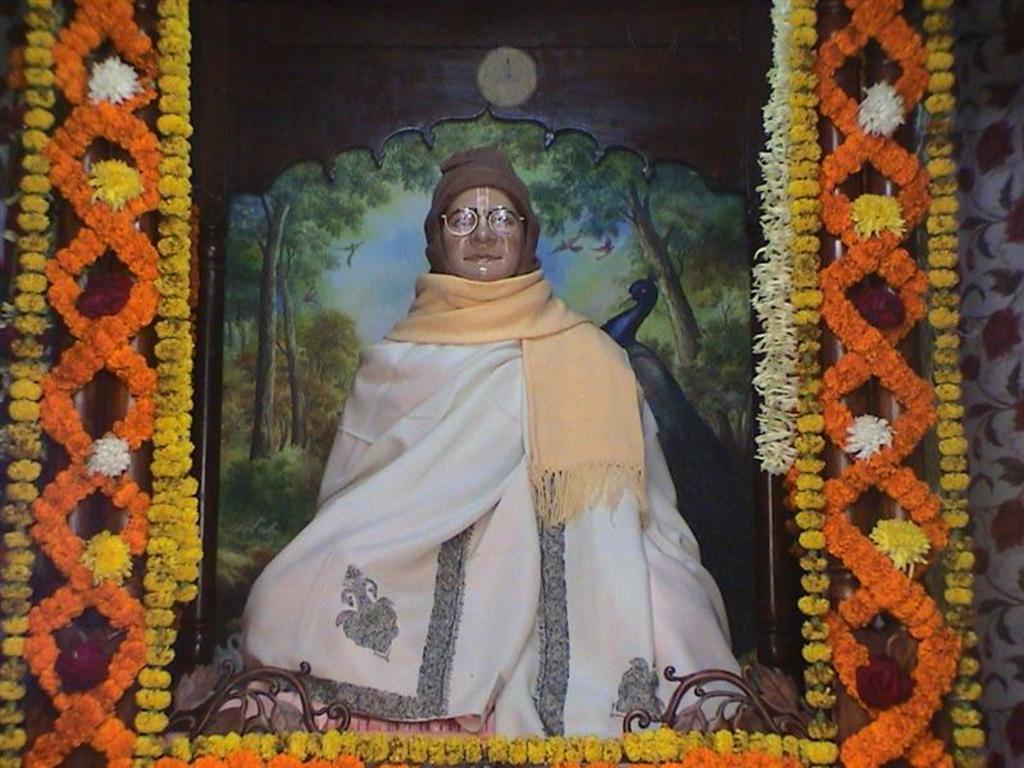In one or two sentences, can you explain what this image depicts? In this picture I can see a statue of a person, there are flowers, garlands, and in the background it looks like a poster. 